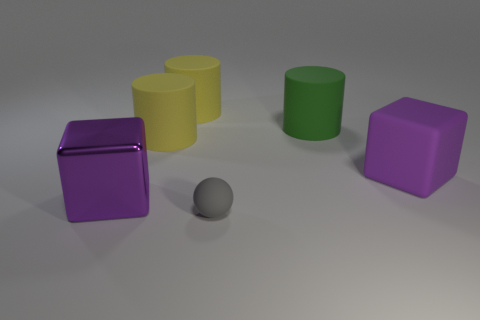Subtract all large green matte cylinders. How many cylinders are left? 2 Add 3 matte spheres. How many objects exist? 9 Subtract all green cylinders. How many cylinders are left? 2 Subtract all spheres. How many objects are left? 5 Subtract all brown blocks. How many green cylinders are left? 1 Subtract all big green rubber objects. Subtract all small gray balls. How many objects are left? 4 Add 2 tiny gray matte balls. How many tiny gray matte balls are left? 3 Add 3 purple matte blocks. How many purple matte blocks exist? 4 Subtract 2 yellow cylinders. How many objects are left? 4 Subtract 2 cubes. How many cubes are left? 0 